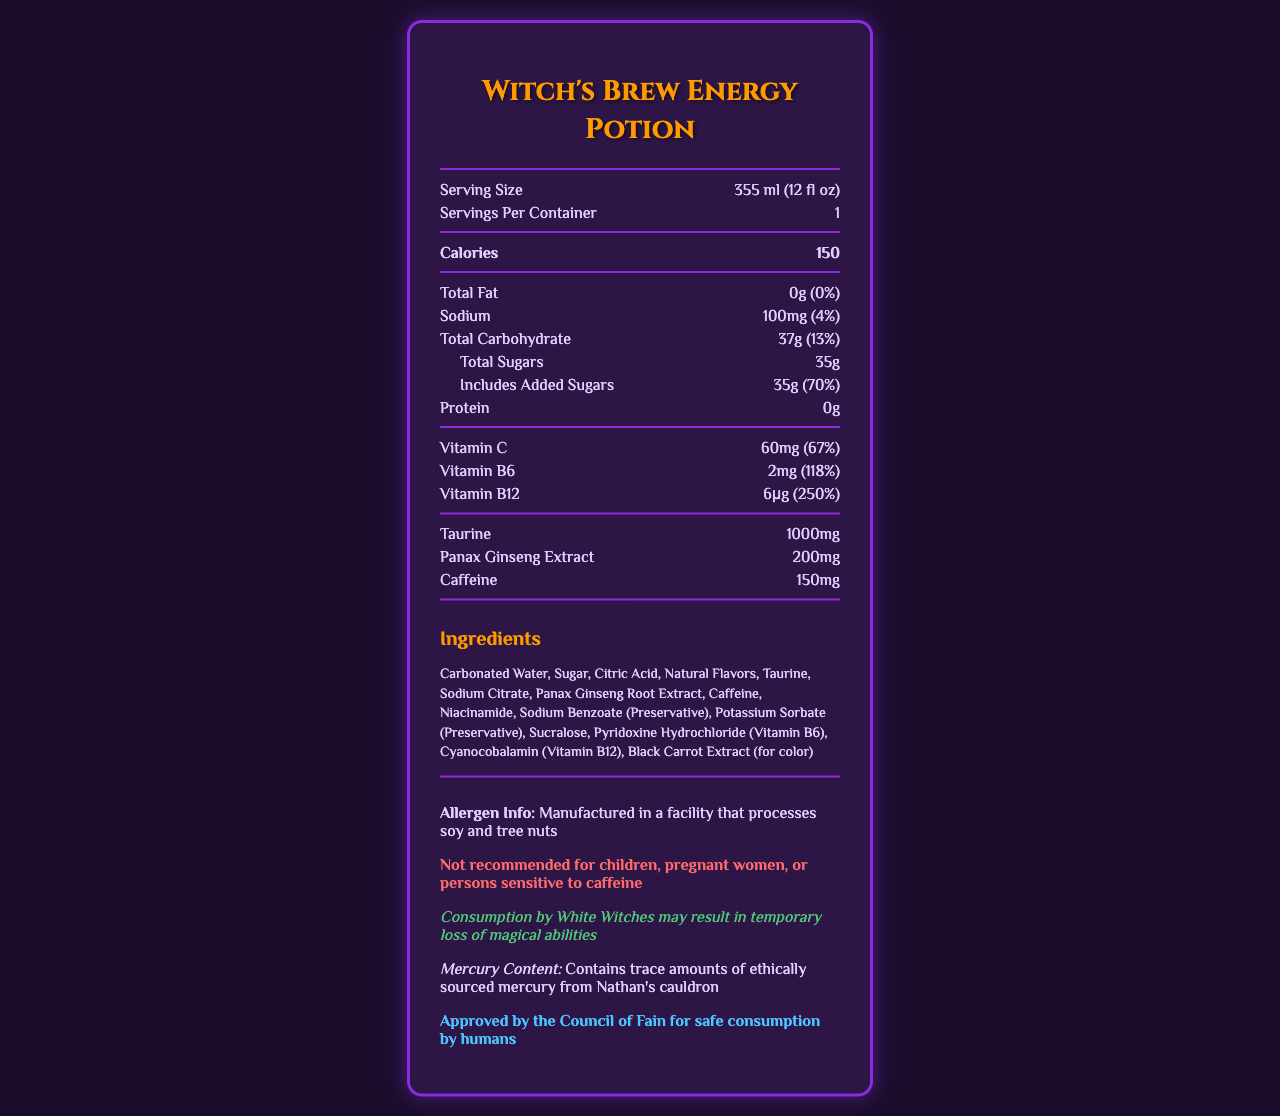what is the serving size of the Witch's Brew Energy Potion? The serving size is listed as 355 ml (12 fl oz) on the document.
Answer: 355 ml (12 fl oz) how many servings are in one container of Witch's Brew Energy Potion? The document indicates that there is 1 serving per container.
Answer: 1 how many calories are in one serving of Witch's Brew Energy Potion? The calories per serving are listed as 150.
Answer: 150 how much sodium is in the drink, and what percentage of the daily value does it represent? The sodium content is 100mg, which is 4% of the daily value.
Answer: 100mg (4%) how much added sugar is in the Witch's Brew Energy Potion? The added sugars amount to 35g, which is 70% of the daily value.
Answer: 35g how much Vitamin B6 is in the drink, and what percentage of the daily value does it represent? The document states that the drink contains 2mg of Vitamin B6, representing 118% of the daily value.
Answer: 2mg (118%) what statement is given about the safety of the Witch's Brew Energy Potion for human consumption? The document includes a statement saying it is approved by the Council of Fain for safe consumption by humans.
Answer: Approved by the Council of Fain for safe consumption by humans does the drink contain any caffeine? If so, how much? The document lists 150mg of caffeine as one of the contents.
Answer: Yes, 150mg which one of these is NOT an ingredient in the Witch's Brew Energy Potion? A. Carbonated Water B. Sugar C. Sodium Chloride D. Natural Flavors The listed ingredients include Carbonated Water, Sugar, and Natural Flavors, but not Sodium Chloride.
Answer: C which nutrient contributes the highest percentage of the daily value in the drink? A. Protein B. Vitamin C C. Vitamin B6 D. Vitamin B12 Vitamin B12 contributes 250% of the daily value, the highest among the listed nutrients.
Answer: D is the Witch's Brew Energy Potion recommended for children or pregnant women? The document explicitly states that the drink is not recommended for children, pregnant women, or persons sensitive to caffeine.
Answer: No please summarize the main idea of the document. The summary captures the entire document by describing its purpose and the main sections including nutritional facts, ingredients, warnings, and endorsements.
Answer: The document provides the nutritional information and ingredients for Witch's Brew Energy Potion. It includes details about serving size, calories, fat, sodium, carbohydrates, sugars, protein, vitamins, and other components such as taurine and caffeine. It also warns about allergens, contains disclaimers for specific populations, and notes its approval by the Council of Fain and a warning for White Witches. how much taurine is in the drink? The document states that the drink contains 1000mg of taurine.
Answer: 1000mg where is the ethically sourced mercury in the drink from? The document states that the mercury content is trace amounts sourced ethically from Nathan's cauldron.
Answer: Nathan's cauldron what percentage of the daily value of carbohydrates does the drink provide? The total carbohydrate content is 37g, which is 13% of the daily value.
Answer: 13% how much protein is in the drink? The document lists that the protein content is 0g.
Answer: 0g can the exact flavor of the Witch's Brew Energy Potion be determined from the document? The document lists "Natural Flavors" in the ingredients, which doesn't provide specific information about the exact flavor.
Answer: Cannot be determined 